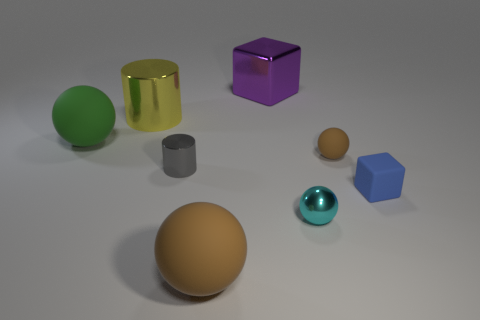There is another sphere that is the same color as the small rubber ball; what size is it?
Keep it short and to the point. Large. How many large things have the same color as the tiny rubber sphere?
Provide a short and direct response. 1. What is the material of the big thing that is right of the large brown thing?
Your answer should be very brief. Metal. What number of things are either large purple objects or matte objects?
Offer a very short reply. 5. How many cyan objects are right of the large purple block?
Make the answer very short. 1. Do the matte block and the small metallic cylinder have the same color?
Provide a succinct answer. No. There is a small blue thing that is made of the same material as the green object; what is its shape?
Your answer should be very brief. Cube. Do the large matte object on the left side of the small gray metal cylinder and the tiny gray object have the same shape?
Your answer should be compact. No. How many blue objects are matte things or large matte blocks?
Keep it short and to the point. 1. Are there the same number of cyan spheres behind the yellow cylinder and tiny gray cylinders that are on the right side of the blue matte thing?
Ensure brevity in your answer.  Yes. 